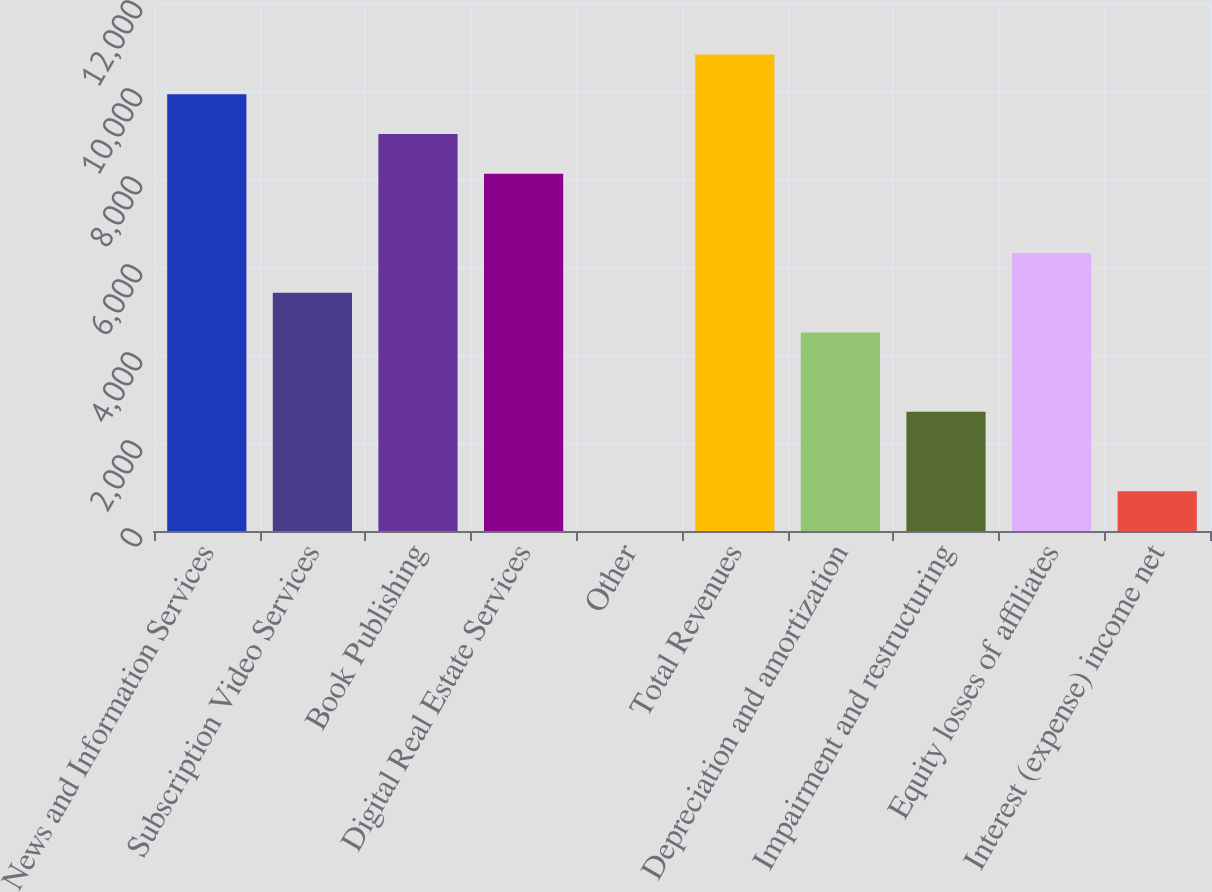<chart> <loc_0><loc_0><loc_500><loc_500><bar_chart><fcel>News and Information Services<fcel>Subscription Video Services<fcel>Book Publishing<fcel>Digital Real Estate Services<fcel>Other<fcel>Total Revenues<fcel>Depreciation and amortization<fcel>Impairment and restructuring<fcel>Equity losses of affiliates<fcel>Interest (expense) income net<nl><fcel>9926.2<fcel>5415.2<fcel>9024<fcel>8121.8<fcel>2<fcel>10828.4<fcel>4513<fcel>2708.6<fcel>6317.4<fcel>904.2<nl></chart> 